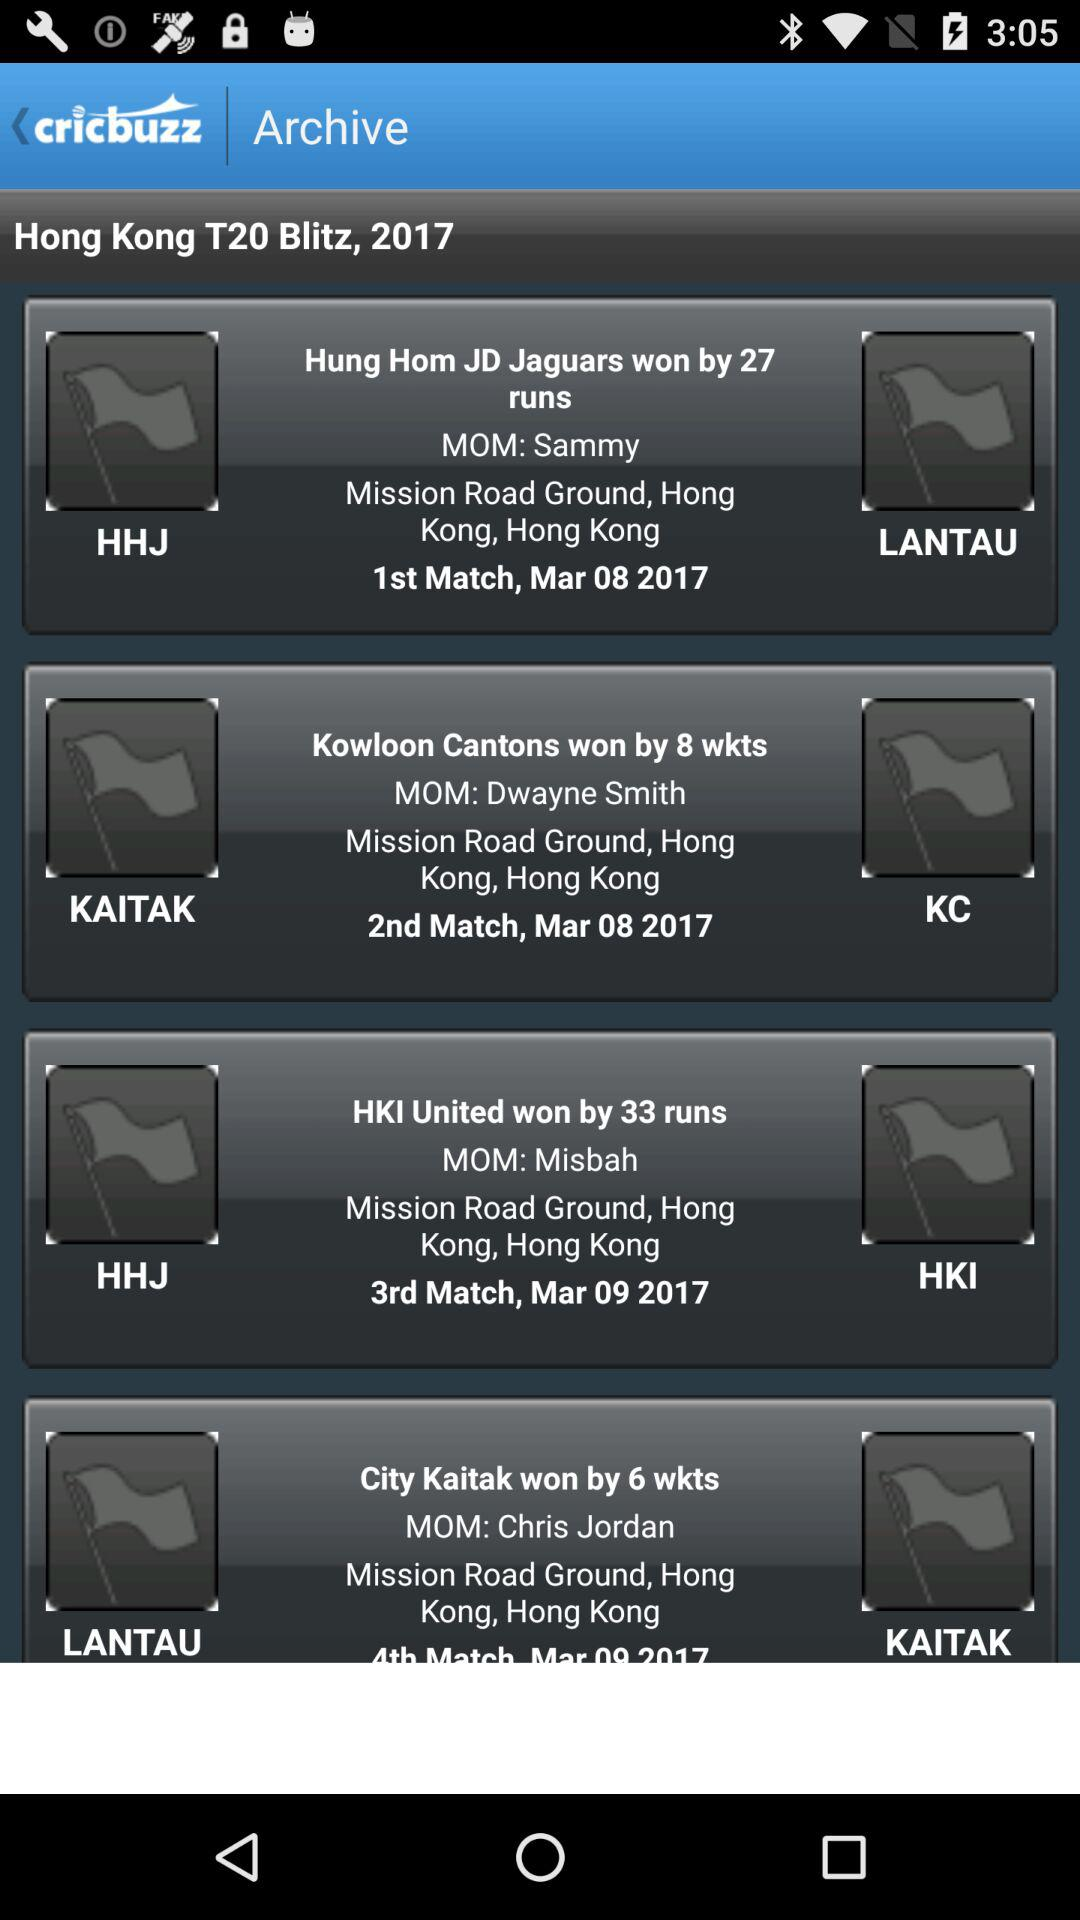Who won the match by 27 runs? The match was won by Hung Hom JD Jaguars. 